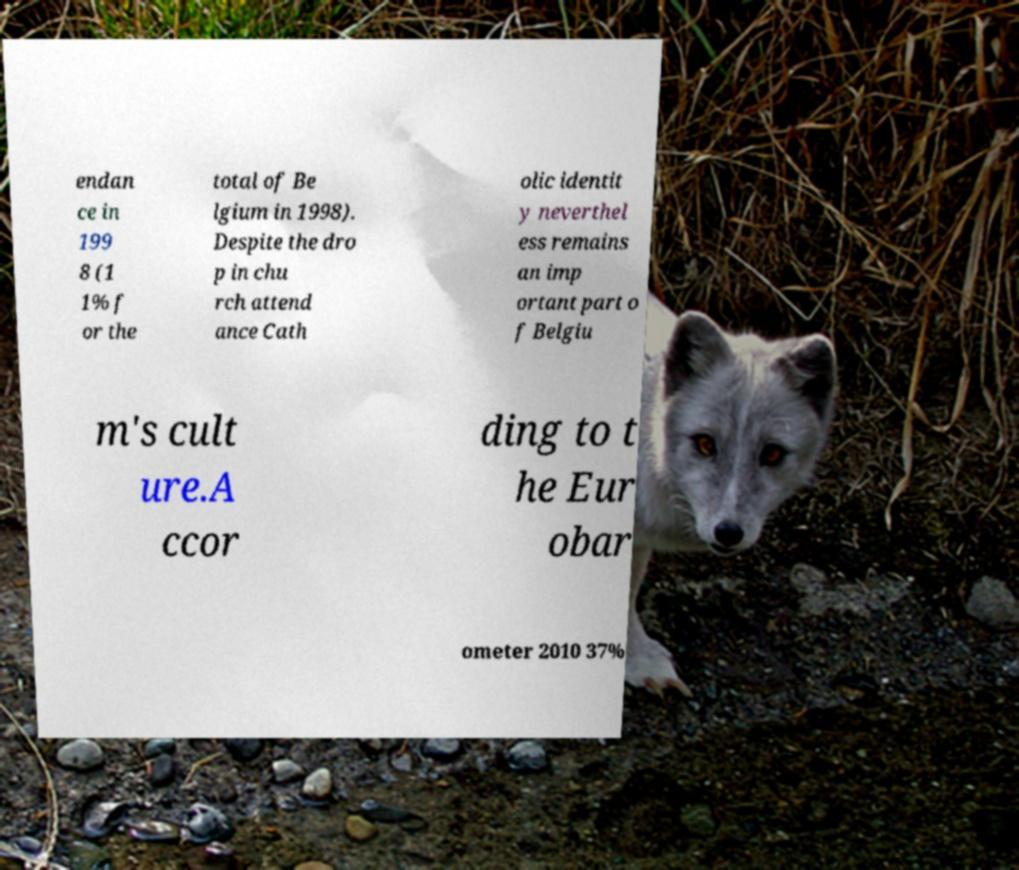I need the written content from this picture converted into text. Can you do that? endan ce in 199 8 (1 1% f or the total of Be lgium in 1998). Despite the dro p in chu rch attend ance Cath olic identit y neverthel ess remains an imp ortant part o f Belgiu m's cult ure.A ccor ding to t he Eur obar ometer 2010 37% 